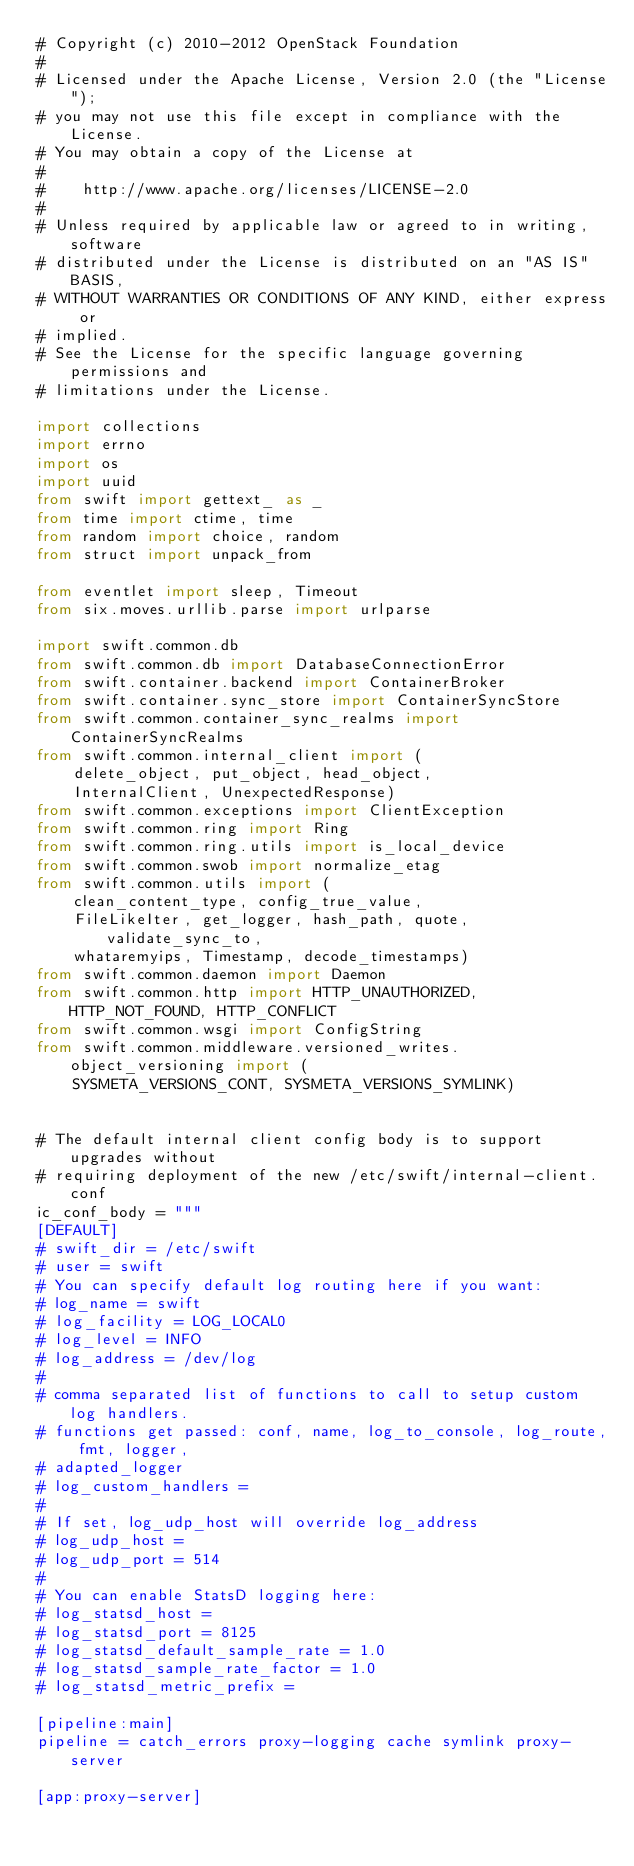<code> <loc_0><loc_0><loc_500><loc_500><_Python_># Copyright (c) 2010-2012 OpenStack Foundation
#
# Licensed under the Apache License, Version 2.0 (the "License");
# you may not use this file except in compliance with the License.
# You may obtain a copy of the License at
#
#    http://www.apache.org/licenses/LICENSE-2.0
#
# Unless required by applicable law or agreed to in writing, software
# distributed under the License is distributed on an "AS IS" BASIS,
# WITHOUT WARRANTIES OR CONDITIONS OF ANY KIND, either express or
# implied.
# See the License for the specific language governing permissions and
# limitations under the License.

import collections
import errno
import os
import uuid
from swift import gettext_ as _
from time import ctime, time
from random import choice, random
from struct import unpack_from

from eventlet import sleep, Timeout
from six.moves.urllib.parse import urlparse

import swift.common.db
from swift.common.db import DatabaseConnectionError
from swift.container.backend import ContainerBroker
from swift.container.sync_store import ContainerSyncStore
from swift.common.container_sync_realms import ContainerSyncRealms
from swift.common.internal_client import (
    delete_object, put_object, head_object,
    InternalClient, UnexpectedResponse)
from swift.common.exceptions import ClientException
from swift.common.ring import Ring
from swift.common.ring.utils import is_local_device
from swift.common.swob import normalize_etag
from swift.common.utils import (
    clean_content_type, config_true_value,
    FileLikeIter, get_logger, hash_path, quote, validate_sync_to,
    whataremyips, Timestamp, decode_timestamps)
from swift.common.daemon import Daemon
from swift.common.http import HTTP_UNAUTHORIZED, HTTP_NOT_FOUND, HTTP_CONFLICT
from swift.common.wsgi import ConfigString
from swift.common.middleware.versioned_writes.object_versioning import (
    SYSMETA_VERSIONS_CONT, SYSMETA_VERSIONS_SYMLINK)


# The default internal client config body is to support upgrades without
# requiring deployment of the new /etc/swift/internal-client.conf
ic_conf_body = """
[DEFAULT]
# swift_dir = /etc/swift
# user = swift
# You can specify default log routing here if you want:
# log_name = swift
# log_facility = LOG_LOCAL0
# log_level = INFO
# log_address = /dev/log
#
# comma separated list of functions to call to setup custom log handlers.
# functions get passed: conf, name, log_to_console, log_route, fmt, logger,
# adapted_logger
# log_custom_handlers =
#
# If set, log_udp_host will override log_address
# log_udp_host =
# log_udp_port = 514
#
# You can enable StatsD logging here:
# log_statsd_host =
# log_statsd_port = 8125
# log_statsd_default_sample_rate = 1.0
# log_statsd_sample_rate_factor = 1.0
# log_statsd_metric_prefix =

[pipeline:main]
pipeline = catch_errors proxy-logging cache symlink proxy-server

[app:proxy-server]</code> 